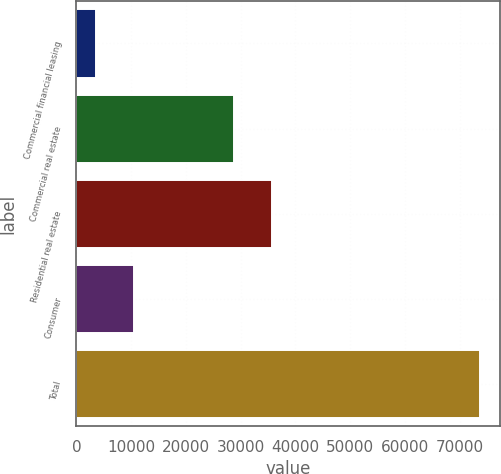<chart> <loc_0><loc_0><loc_500><loc_500><bar_chart><fcel>Commercial financial leasing<fcel>Commercial real estate<fcel>Residential real estate<fcel>Consumer<fcel>Total<nl><fcel>3586<fcel>28783<fcel>35797.5<fcel>10600.5<fcel>73731<nl></chart> 